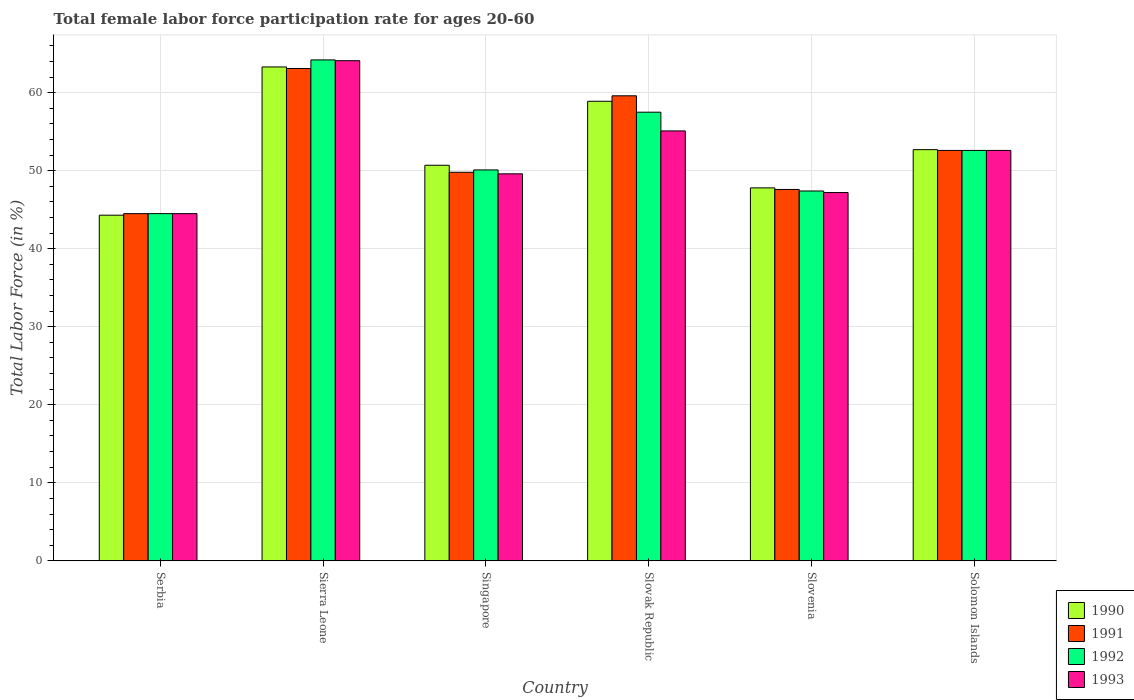How many groups of bars are there?
Provide a succinct answer. 6. Are the number of bars on each tick of the X-axis equal?
Provide a short and direct response. Yes. How many bars are there on the 1st tick from the left?
Provide a succinct answer. 4. How many bars are there on the 6th tick from the right?
Provide a succinct answer. 4. What is the label of the 1st group of bars from the left?
Offer a terse response. Serbia. In how many cases, is the number of bars for a given country not equal to the number of legend labels?
Give a very brief answer. 0. What is the female labor force participation rate in 1993 in Sierra Leone?
Make the answer very short. 64.1. Across all countries, what is the maximum female labor force participation rate in 1992?
Give a very brief answer. 64.2. Across all countries, what is the minimum female labor force participation rate in 1990?
Keep it short and to the point. 44.3. In which country was the female labor force participation rate in 1993 maximum?
Offer a terse response. Sierra Leone. In which country was the female labor force participation rate in 1993 minimum?
Your answer should be very brief. Serbia. What is the total female labor force participation rate in 1991 in the graph?
Your answer should be very brief. 317.2. What is the difference between the female labor force participation rate in 1993 in Slovak Republic and that in Slovenia?
Your answer should be compact. 7.9. What is the difference between the female labor force participation rate in 1991 in Slovenia and the female labor force participation rate in 1993 in Serbia?
Offer a terse response. 3.1. What is the average female labor force participation rate in 1991 per country?
Offer a terse response. 52.87. What is the difference between the female labor force participation rate of/in 1993 and female labor force participation rate of/in 1990 in Singapore?
Offer a terse response. -1.1. What is the ratio of the female labor force participation rate in 1990 in Sierra Leone to that in Slovenia?
Your answer should be compact. 1.32. Is the female labor force participation rate in 1991 in Sierra Leone less than that in Slovak Republic?
Your response must be concise. No. Is the difference between the female labor force participation rate in 1993 in Slovak Republic and Solomon Islands greater than the difference between the female labor force participation rate in 1990 in Slovak Republic and Solomon Islands?
Give a very brief answer. No. What is the difference between the highest and the second highest female labor force participation rate in 1992?
Your response must be concise. 6.7. What is the difference between the highest and the lowest female labor force participation rate in 1992?
Offer a very short reply. 19.7. Is it the case that in every country, the sum of the female labor force participation rate in 1992 and female labor force participation rate in 1993 is greater than the sum of female labor force participation rate in 1990 and female labor force participation rate in 1991?
Keep it short and to the point. No. What does the 3rd bar from the right in Solomon Islands represents?
Offer a very short reply. 1991. Is it the case that in every country, the sum of the female labor force participation rate in 1993 and female labor force participation rate in 1990 is greater than the female labor force participation rate in 1991?
Provide a short and direct response. Yes. How many bars are there?
Your answer should be compact. 24. Are all the bars in the graph horizontal?
Give a very brief answer. No. What is the difference between two consecutive major ticks on the Y-axis?
Your response must be concise. 10. Are the values on the major ticks of Y-axis written in scientific E-notation?
Give a very brief answer. No. Does the graph contain any zero values?
Offer a very short reply. No. Does the graph contain grids?
Keep it short and to the point. Yes. Where does the legend appear in the graph?
Give a very brief answer. Bottom right. What is the title of the graph?
Make the answer very short. Total female labor force participation rate for ages 20-60. What is the label or title of the Y-axis?
Ensure brevity in your answer.  Total Labor Force (in %). What is the Total Labor Force (in %) of 1990 in Serbia?
Offer a terse response. 44.3. What is the Total Labor Force (in %) of 1991 in Serbia?
Ensure brevity in your answer.  44.5. What is the Total Labor Force (in %) of 1992 in Serbia?
Make the answer very short. 44.5. What is the Total Labor Force (in %) in 1993 in Serbia?
Provide a succinct answer. 44.5. What is the Total Labor Force (in %) in 1990 in Sierra Leone?
Your answer should be very brief. 63.3. What is the Total Labor Force (in %) in 1991 in Sierra Leone?
Your response must be concise. 63.1. What is the Total Labor Force (in %) in 1992 in Sierra Leone?
Provide a short and direct response. 64.2. What is the Total Labor Force (in %) in 1993 in Sierra Leone?
Your answer should be very brief. 64.1. What is the Total Labor Force (in %) of 1990 in Singapore?
Your answer should be very brief. 50.7. What is the Total Labor Force (in %) in 1991 in Singapore?
Provide a succinct answer. 49.8. What is the Total Labor Force (in %) in 1992 in Singapore?
Your answer should be very brief. 50.1. What is the Total Labor Force (in %) of 1993 in Singapore?
Keep it short and to the point. 49.6. What is the Total Labor Force (in %) in 1990 in Slovak Republic?
Ensure brevity in your answer.  58.9. What is the Total Labor Force (in %) of 1991 in Slovak Republic?
Your answer should be compact. 59.6. What is the Total Labor Force (in %) of 1992 in Slovak Republic?
Your response must be concise. 57.5. What is the Total Labor Force (in %) in 1993 in Slovak Republic?
Ensure brevity in your answer.  55.1. What is the Total Labor Force (in %) of 1990 in Slovenia?
Offer a terse response. 47.8. What is the Total Labor Force (in %) in 1991 in Slovenia?
Provide a short and direct response. 47.6. What is the Total Labor Force (in %) in 1992 in Slovenia?
Ensure brevity in your answer.  47.4. What is the Total Labor Force (in %) in 1993 in Slovenia?
Your response must be concise. 47.2. What is the Total Labor Force (in %) in 1990 in Solomon Islands?
Ensure brevity in your answer.  52.7. What is the Total Labor Force (in %) of 1991 in Solomon Islands?
Your answer should be compact. 52.6. What is the Total Labor Force (in %) of 1992 in Solomon Islands?
Your answer should be very brief. 52.6. What is the Total Labor Force (in %) in 1993 in Solomon Islands?
Your answer should be very brief. 52.6. Across all countries, what is the maximum Total Labor Force (in %) in 1990?
Offer a very short reply. 63.3. Across all countries, what is the maximum Total Labor Force (in %) in 1991?
Provide a short and direct response. 63.1. Across all countries, what is the maximum Total Labor Force (in %) in 1992?
Your answer should be very brief. 64.2. Across all countries, what is the maximum Total Labor Force (in %) of 1993?
Your response must be concise. 64.1. Across all countries, what is the minimum Total Labor Force (in %) of 1990?
Your response must be concise. 44.3. Across all countries, what is the minimum Total Labor Force (in %) in 1991?
Make the answer very short. 44.5. Across all countries, what is the minimum Total Labor Force (in %) of 1992?
Provide a succinct answer. 44.5. Across all countries, what is the minimum Total Labor Force (in %) of 1993?
Offer a terse response. 44.5. What is the total Total Labor Force (in %) of 1990 in the graph?
Make the answer very short. 317.7. What is the total Total Labor Force (in %) in 1991 in the graph?
Ensure brevity in your answer.  317.2. What is the total Total Labor Force (in %) of 1992 in the graph?
Provide a succinct answer. 316.3. What is the total Total Labor Force (in %) in 1993 in the graph?
Keep it short and to the point. 313.1. What is the difference between the Total Labor Force (in %) of 1990 in Serbia and that in Sierra Leone?
Provide a short and direct response. -19. What is the difference between the Total Labor Force (in %) in 1991 in Serbia and that in Sierra Leone?
Keep it short and to the point. -18.6. What is the difference between the Total Labor Force (in %) of 1992 in Serbia and that in Sierra Leone?
Provide a short and direct response. -19.7. What is the difference between the Total Labor Force (in %) of 1993 in Serbia and that in Sierra Leone?
Offer a terse response. -19.6. What is the difference between the Total Labor Force (in %) of 1993 in Serbia and that in Singapore?
Provide a short and direct response. -5.1. What is the difference between the Total Labor Force (in %) in 1990 in Serbia and that in Slovak Republic?
Offer a very short reply. -14.6. What is the difference between the Total Labor Force (in %) in 1991 in Serbia and that in Slovak Republic?
Your answer should be compact. -15.1. What is the difference between the Total Labor Force (in %) in 1992 in Serbia and that in Slovak Republic?
Provide a short and direct response. -13. What is the difference between the Total Labor Force (in %) of 1993 in Serbia and that in Slovak Republic?
Your answer should be compact. -10.6. What is the difference between the Total Labor Force (in %) of 1990 in Serbia and that in Slovenia?
Keep it short and to the point. -3.5. What is the difference between the Total Labor Force (in %) in 1990 in Serbia and that in Solomon Islands?
Provide a short and direct response. -8.4. What is the difference between the Total Labor Force (in %) of 1991 in Serbia and that in Solomon Islands?
Keep it short and to the point. -8.1. What is the difference between the Total Labor Force (in %) in 1992 in Serbia and that in Solomon Islands?
Make the answer very short. -8.1. What is the difference between the Total Labor Force (in %) of 1993 in Serbia and that in Solomon Islands?
Your answer should be very brief. -8.1. What is the difference between the Total Labor Force (in %) in 1990 in Sierra Leone and that in Singapore?
Your response must be concise. 12.6. What is the difference between the Total Labor Force (in %) in 1991 in Sierra Leone and that in Singapore?
Ensure brevity in your answer.  13.3. What is the difference between the Total Labor Force (in %) of 1993 in Sierra Leone and that in Singapore?
Provide a succinct answer. 14.5. What is the difference between the Total Labor Force (in %) of 1990 in Sierra Leone and that in Slovak Republic?
Give a very brief answer. 4.4. What is the difference between the Total Labor Force (in %) in 1991 in Sierra Leone and that in Slovak Republic?
Offer a very short reply. 3.5. What is the difference between the Total Labor Force (in %) of 1993 in Sierra Leone and that in Slovak Republic?
Offer a terse response. 9. What is the difference between the Total Labor Force (in %) of 1990 in Sierra Leone and that in Slovenia?
Your answer should be compact. 15.5. What is the difference between the Total Labor Force (in %) in 1993 in Sierra Leone and that in Slovenia?
Keep it short and to the point. 16.9. What is the difference between the Total Labor Force (in %) in 1990 in Sierra Leone and that in Solomon Islands?
Make the answer very short. 10.6. What is the difference between the Total Labor Force (in %) of 1992 in Sierra Leone and that in Solomon Islands?
Ensure brevity in your answer.  11.6. What is the difference between the Total Labor Force (in %) in 1993 in Sierra Leone and that in Solomon Islands?
Provide a succinct answer. 11.5. What is the difference between the Total Labor Force (in %) in 1990 in Singapore and that in Slovak Republic?
Make the answer very short. -8.2. What is the difference between the Total Labor Force (in %) in 1991 in Singapore and that in Slovak Republic?
Offer a very short reply. -9.8. What is the difference between the Total Labor Force (in %) of 1992 in Singapore and that in Slovak Republic?
Your answer should be compact. -7.4. What is the difference between the Total Labor Force (in %) in 1990 in Singapore and that in Slovenia?
Your response must be concise. 2.9. What is the difference between the Total Labor Force (in %) in 1991 in Singapore and that in Slovenia?
Provide a succinct answer. 2.2. What is the difference between the Total Labor Force (in %) of 1992 in Singapore and that in Slovenia?
Your answer should be compact. 2.7. What is the difference between the Total Labor Force (in %) of 1993 in Singapore and that in Solomon Islands?
Your response must be concise. -3. What is the difference between the Total Labor Force (in %) of 1991 in Slovak Republic and that in Slovenia?
Provide a succinct answer. 12. What is the difference between the Total Labor Force (in %) of 1991 in Slovak Republic and that in Solomon Islands?
Offer a very short reply. 7. What is the difference between the Total Labor Force (in %) in 1992 in Slovak Republic and that in Solomon Islands?
Your response must be concise. 4.9. What is the difference between the Total Labor Force (in %) of 1993 in Slovak Republic and that in Solomon Islands?
Ensure brevity in your answer.  2.5. What is the difference between the Total Labor Force (in %) of 1992 in Slovenia and that in Solomon Islands?
Offer a terse response. -5.2. What is the difference between the Total Labor Force (in %) of 1993 in Slovenia and that in Solomon Islands?
Provide a short and direct response. -5.4. What is the difference between the Total Labor Force (in %) of 1990 in Serbia and the Total Labor Force (in %) of 1991 in Sierra Leone?
Offer a terse response. -18.8. What is the difference between the Total Labor Force (in %) in 1990 in Serbia and the Total Labor Force (in %) in 1992 in Sierra Leone?
Offer a very short reply. -19.9. What is the difference between the Total Labor Force (in %) in 1990 in Serbia and the Total Labor Force (in %) in 1993 in Sierra Leone?
Your answer should be compact. -19.8. What is the difference between the Total Labor Force (in %) of 1991 in Serbia and the Total Labor Force (in %) of 1992 in Sierra Leone?
Provide a succinct answer. -19.7. What is the difference between the Total Labor Force (in %) of 1991 in Serbia and the Total Labor Force (in %) of 1993 in Sierra Leone?
Your answer should be compact. -19.6. What is the difference between the Total Labor Force (in %) in 1992 in Serbia and the Total Labor Force (in %) in 1993 in Sierra Leone?
Ensure brevity in your answer.  -19.6. What is the difference between the Total Labor Force (in %) in 1990 in Serbia and the Total Labor Force (in %) in 1991 in Singapore?
Make the answer very short. -5.5. What is the difference between the Total Labor Force (in %) of 1990 in Serbia and the Total Labor Force (in %) of 1993 in Singapore?
Make the answer very short. -5.3. What is the difference between the Total Labor Force (in %) in 1990 in Serbia and the Total Labor Force (in %) in 1991 in Slovak Republic?
Give a very brief answer. -15.3. What is the difference between the Total Labor Force (in %) in 1990 in Serbia and the Total Labor Force (in %) in 1992 in Slovak Republic?
Keep it short and to the point. -13.2. What is the difference between the Total Labor Force (in %) of 1990 in Serbia and the Total Labor Force (in %) of 1993 in Slovak Republic?
Provide a short and direct response. -10.8. What is the difference between the Total Labor Force (in %) in 1991 in Serbia and the Total Labor Force (in %) in 1992 in Slovak Republic?
Offer a very short reply. -13. What is the difference between the Total Labor Force (in %) in 1991 in Serbia and the Total Labor Force (in %) in 1993 in Slovak Republic?
Your answer should be compact. -10.6. What is the difference between the Total Labor Force (in %) of 1992 in Serbia and the Total Labor Force (in %) of 1993 in Slovak Republic?
Your response must be concise. -10.6. What is the difference between the Total Labor Force (in %) of 1990 in Serbia and the Total Labor Force (in %) of 1991 in Slovenia?
Offer a terse response. -3.3. What is the difference between the Total Labor Force (in %) in 1991 in Serbia and the Total Labor Force (in %) in 1992 in Slovenia?
Provide a short and direct response. -2.9. What is the difference between the Total Labor Force (in %) of 1992 in Serbia and the Total Labor Force (in %) of 1993 in Slovenia?
Offer a very short reply. -2.7. What is the difference between the Total Labor Force (in %) in 1990 in Serbia and the Total Labor Force (in %) in 1992 in Solomon Islands?
Make the answer very short. -8.3. What is the difference between the Total Labor Force (in %) in 1990 in Serbia and the Total Labor Force (in %) in 1993 in Solomon Islands?
Your answer should be very brief. -8.3. What is the difference between the Total Labor Force (in %) in 1991 in Serbia and the Total Labor Force (in %) in 1993 in Solomon Islands?
Provide a short and direct response. -8.1. What is the difference between the Total Labor Force (in %) of 1992 in Serbia and the Total Labor Force (in %) of 1993 in Solomon Islands?
Offer a very short reply. -8.1. What is the difference between the Total Labor Force (in %) of 1990 in Sierra Leone and the Total Labor Force (in %) of 1991 in Singapore?
Your answer should be very brief. 13.5. What is the difference between the Total Labor Force (in %) in 1990 in Sierra Leone and the Total Labor Force (in %) in 1993 in Singapore?
Give a very brief answer. 13.7. What is the difference between the Total Labor Force (in %) in 1990 in Sierra Leone and the Total Labor Force (in %) in 1992 in Slovak Republic?
Provide a succinct answer. 5.8. What is the difference between the Total Labor Force (in %) in 1990 in Sierra Leone and the Total Labor Force (in %) in 1993 in Slovak Republic?
Your answer should be very brief. 8.2. What is the difference between the Total Labor Force (in %) of 1991 in Sierra Leone and the Total Labor Force (in %) of 1993 in Slovak Republic?
Offer a terse response. 8. What is the difference between the Total Labor Force (in %) of 1992 in Sierra Leone and the Total Labor Force (in %) of 1993 in Slovak Republic?
Offer a terse response. 9.1. What is the difference between the Total Labor Force (in %) of 1990 in Sierra Leone and the Total Labor Force (in %) of 1993 in Slovenia?
Provide a short and direct response. 16.1. What is the difference between the Total Labor Force (in %) in 1992 in Sierra Leone and the Total Labor Force (in %) in 1993 in Slovenia?
Offer a terse response. 17. What is the difference between the Total Labor Force (in %) of 1990 in Sierra Leone and the Total Labor Force (in %) of 1992 in Solomon Islands?
Provide a short and direct response. 10.7. What is the difference between the Total Labor Force (in %) of 1990 in Sierra Leone and the Total Labor Force (in %) of 1993 in Solomon Islands?
Provide a succinct answer. 10.7. What is the difference between the Total Labor Force (in %) in 1991 in Sierra Leone and the Total Labor Force (in %) in 1993 in Solomon Islands?
Your answer should be compact. 10.5. What is the difference between the Total Labor Force (in %) of 1990 in Singapore and the Total Labor Force (in %) of 1991 in Slovak Republic?
Your response must be concise. -8.9. What is the difference between the Total Labor Force (in %) of 1990 in Singapore and the Total Labor Force (in %) of 1992 in Slovak Republic?
Your answer should be very brief. -6.8. What is the difference between the Total Labor Force (in %) in 1991 in Singapore and the Total Labor Force (in %) in 1992 in Slovak Republic?
Provide a succinct answer. -7.7. What is the difference between the Total Labor Force (in %) in 1990 in Singapore and the Total Labor Force (in %) in 1991 in Slovenia?
Make the answer very short. 3.1. What is the difference between the Total Labor Force (in %) of 1990 in Singapore and the Total Labor Force (in %) of 1992 in Slovenia?
Offer a terse response. 3.3. What is the difference between the Total Labor Force (in %) in 1990 in Singapore and the Total Labor Force (in %) in 1993 in Slovenia?
Offer a terse response. 3.5. What is the difference between the Total Labor Force (in %) of 1991 in Singapore and the Total Labor Force (in %) of 1992 in Slovenia?
Keep it short and to the point. 2.4. What is the difference between the Total Labor Force (in %) of 1992 in Singapore and the Total Labor Force (in %) of 1993 in Slovenia?
Provide a short and direct response. 2.9. What is the difference between the Total Labor Force (in %) in 1990 in Singapore and the Total Labor Force (in %) in 1991 in Solomon Islands?
Keep it short and to the point. -1.9. What is the difference between the Total Labor Force (in %) in 1990 in Singapore and the Total Labor Force (in %) in 1993 in Solomon Islands?
Your response must be concise. -1.9. What is the difference between the Total Labor Force (in %) of 1992 in Singapore and the Total Labor Force (in %) of 1993 in Solomon Islands?
Ensure brevity in your answer.  -2.5. What is the difference between the Total Labor Force (in %) of 1990 in Slovak Republic and the Total Labor Force (in %) of 1991 in Slovenia?
Your answer should be very brief. 11.3. What is the difference between the Total Labor Force (in %) of 1990 in Slovak Republic and the Total Labor Force (in %) of 1992 in Slovenia?
Keep it short and to the point. 11.5. What is the difference between the Total Labor Force (in %) in 1991 in Slovak Republic and the Total Labor Force (in %) in 1992 in Slovenia?
Provide a succinct answer. 12.2. What is the difference between the Total Labor Force (in %) of 1991 in Slovak Republic and the Total Labor Force (in %) of 1993 in Slovenia?
Provide a succinct answer. 12.4. What is the difference between the Total Labor Force (in %) of 1990 in Slovak Republic and the Total Labor Force (in %) of 1991 in Solomon Islands?
Keep it short and to the point. 6.3. What is the difference between the Total Labor Force (in %) of 1990 in Slovak Republic and the Total Labor Force (in %) of 1993 in Solomon Islands?
Your answer should be very brief. 6.3. What is the difference between the Total Labor Force (in %) of 1991 in Slovak Republic and the Total Labor Force (in %) of 1992 in Solomon Islands?
Make the answer very short. 7. What is the difference between the Total Labor Force (in %) in 1990 in Slovenia and the Total Labor Force (in %) in 1991 in Solomon Islands?
Provide a succinct answer. -4.8. What is the difference between the Total Labor Force (in %) of 1990 in Slovenia and the Total Labor Force (in %) of 1992 in Solomon Islands?
Offer a terse response. -4.8. What is the difference between the Total Labor Force (in %) in 1991 in Slovenia and the Total Labor Force (in %) in 1992 in Solomon Islands?
Offer a very short reply. -5. What is the difference between the Total Labor Force (in %) in 1991 in Slovenia and the Total Labor Force (in %) in 1993 in Solomon Islands?
Provide a short and direct response. -5. What is the average Total Labor Force (in %) of 1990 per country?
Your answer should be very brief. 52.95. What is the average Total Labor Force (in %) of 1991 per country?
Provide a short and direct response. 52.87. What is the average Total Labor Force (in %) of 1992 per country?
Your response must be concise. 52.72. What is the average Total Labor Force (in %) of 1993 per country?
Keep it short and to the point. 52.18. What is the difference between the Total Labor Force (in %) of 1990 and Total Labor Force (in %) of 1992 in Serbia?
Keep it short and to the point. -0.2. What is the difference between the Total Labor Force (in %) in 1990 and Total Labor Force (in %) in 1993 in Serbia?
Give a very brief answer. -0.2. What is the difference between the Total Labor Force (in %) of 1991 and Total Labor Force (in %) of 1992 in Serbia?
Your answer should be very brief. 0. What is the difference between the Total Labor Force (in %) of 1992 and Total Labor Force (in %) of 1993 in Serbia?
Your answer should be compact. 0. What is the difference between the Total Labor Force (in %) of 1990 and Total Labor Force (in %) of 1991 in Sierra Leone?
Offer a terse response. 0.2. What is the difference between the Total Labor Force (in %) in 1990 and Total Labor Force (in %) in 1992 in Sierra Leone?
Give a very brief answer. -0.9. What is the difference between the Total Labor Force (in %) in 1990 and Total Labor Force (in %) in 1993 in Sierra Leone?
Offer a terse response. -0.8. What is the difference between the Total Labor Force (in %) in 1991 and Total Labor Force (in %) in 1992 in Sierra Leone?
Your answer should be compact. -1.1. What is the difference between the Total Labor Force (in %) in 1992 and Total Labor Force (in %) in 1993 in Sierra Leone?
Offer a terse response. 0.1. What is the difference between the Total Labor Force (in %) of 1990 and Total Labor Force (in %) of 1991 in Singapore?
Your answer should be very brief. 0.9. What is the difference between the Total Labor Force (in %) of 1990 and Total Labor Force (in %) of 1992 in Singapore?
Your answer should be compact. 0.6. What is the difference between the Total Labor Force (in %) of 1991 and Total Labor Force (in %) of 1993 in Singapore?
Ensure brevity in your answer.  0.2. What is the difference between the Total Labor Force (in %) of 1992 and Total Labor Force (in %) of 1993 in Slovak Republic?
Keep it short and to the point. 2.4. What is the difference between the Total Labor Force (in %) of 1990 and Total Labor Force (in %) of 1992 in Slovenia?
Your response must be concise. 0.4. What is the difference between the Total Labor Force (in %) in 1991 and Total Labor Force (in %) in 1993 in Slovenia?
Offer a very short reply. 0.4. What is the difference between the Total Labor Force (in %) of 1992 and Total Labor Force (in %) of 1993 in Slovenia?
Your response must be concise. 0.2. What is the difference between the Total Labor Force (in %) in 1990 and Total Labor Force (in %) in 1991 in Solomon Islands?
Your response must be concise. 0.1. What is the difference between the Total Labor Force (in %) in 1990 and Total Labor Force (in %) in 1992 in Solomon Islands?
Offer a very short reply. 0.1. What is the difference between the Total Labor Force (in %) in 1990 and Total Labor Force (in %) in 1993 in Solomon Islands?
Make the answer very short. 0.1. What is the difference between the Total Labor Force (in %) in 1991 and Total Labor Force (in %) in 1993 in Solomon Islands?
Give a very brief answer. 0. What is the ratio of the Total Labor Force (in %) in 1990 in Serbia to that in Sierra Leone?
Offer a very short reply. 0.7. What is the ratio of the Total Labor Force (in %) of 1991 in Serbia to that in Sierra Leone?
Give a very brief answer. 0.71. What is the ratio of the Total Labor Force (in %) of 1992 in Serbia to that in Sierra Leone?
Keep it short and to the point. 0.69. What is the ratio of the Total Labor Force (in %) in 1993 in Serbia to that in Sierra Leone?
Ensure brevity in your answer.  0.69. What is the ratio of the Total Labor Force (in %) in 1990 in Serbia to that in Singapore?
Your response must be concise. 0.87. What is the ratio of the Total Labor Force (in %) in 1991 in Serbia to that in Singapore?
Keep it short and to the point. 0.89. What is the ratio of the Total Labor Force (in %) in 1992 in Serbia to that in Singapore?
Offer a very short reply. 0.89. What is the ratio of the Total Labor Force (in %) of 1993 in Serbia to that in Singapore?
Keep it short and to the point. 0.9. What is the ratio of the Total Labor Force (in %) in 1990 in Serbia to that in Slovak Republic?
Ensure brevity in your answer.  0.75. What is the ratio of the Total Labor Force (in %) in 1991 in Serbia to that in Slovak Republic?
Provide a succinct answer. 0.75. What is the ratio of the Total Labor Force (in %) of 1992 in Serbia to that in Slovak Republic?
Ensure brevity in your answer.  0.77. What is the ratio of the Total Labor Force (in %) of 1993 in Serbia to that in Slovak Republic?
Keep it short and to the point. 0.81. What is the ratio of the Total Labor Force (in %) in 1990 in Serbia to that in Slovenia?
Make the answer very short. 0.93. What is the ratio of the Total Labor Force (in %) of 1991 in Serbia to that in Slovenia?
Ensure brevity in your answer.  0.93. What is the ratio of the Total Labor Force (in %) in 1992 in Serbia to that in Slovenia?
Keep it short and to the point. 0.94. What is the ratio of the Total Labor Force (in %) of 1993 in Serbia to that in Slovenia?
Your answer should be very brief. 0.94. What is the ratio of the Total Labor Force (in %) of 1990 in Serbia to that in Solomon Islands?
Ensure brevity in your answer.  0.84. What is the ratio of the Total Labor Force (in %) in 1991 in Serbia to that in Solomon Islands?
Make the answer very short. 0.85. What is the ratio of the Total Labor Force (in %) of 1992 in Serbia to that in Solomon Islands?
Your response must be concise. 0.85. What is the ratio of the Total Labor Force (in %) in 1993 in Serbia to that in Solomon Islands?
Your answer should be compact. 0.85. What is the ratio of the Total Labor Force (in %) of 1990 in Sierra Leone to that in Singapore?
Your answer should be very brief. 1.25. What is the ratio of the Total Labor Force (in %) in 1991 in Sierra Leone to that in Singapore?
Ensure brevity in your answer.  1.27. What is the ratio of the Total Labor Force (in %) of 1992 in Sierra Leone to that in Singapore?
Keep it short and to the point. 1.28. What is the ratio of the Total Labor Force (in %) in 1993 in Sierra Leone to that in Singapore?
Give a very brief answer. 1.29. What is the ratio of the Total Labor Force (in %) of 1990 in Sierra Leone to that in Slovak Republic?
Ensure brevity in your answer.  1.07. What is the ratio of the Total Labor Force (in %) of 1991 in Sierra Leone to that in Slovak Republic?
Give a very brief answer. 1.06. What is the ratio of the Total Labor Force (in %) of 1992 in Sierra Leone to that in Slovak Republic?
Make the answer very short. 1.12. What is the ratio of the Total Labor Force (in %) of 1993 in Sierra Leone to that in Slovak Republic?
Provide a succinct answer. 1.16. What is the ratio of the Total Labor Force (in %) in 1990 in Sierra Leone to that in Slovenia?
Provide a short and direct response. 1.32. What is the ratio of the Total Labor Force (in %) of 1991 in Sierra Leone to that in Slovenia?
Keep it short and to the point. 1.33. What is the ratio of the Total Labor Force (in %) of 1992 in Sierra Leone to that in Slovenia?
Give a very brief answer. 1.35. What is the ratio of the Total Labor Force (in %) in 1993 in Sierra Leone to that in Slovenia?
Your answer should be very brief. 1.36. What is the ratio of the Total Labor Force (in %) in 1990 in Sierra Leone to that in Solomon Islands?
Your response must be concise. 1.2. What is the ratio of the Total Labor Force (in %) of 1991 in Sierra Leone to that in Solomon Islands?
Give a very brief answer. 1.2. What is the ratio of the Total Labor Force (in %) of 1992 in Sierra Leone to that in Solomon Islands?
Your answer should be compact. 1.22. What is the ratio of the Total Labor Force (in %) in 1993 in Sierra Leone to that in Solomon Islands?
Your response must be concise. 1.22. What is the ratio of the Total Labor Force (in %) of 1990 in Singapore to that in Slovak Republic?
Make the answer very short. 0.86. What is the ratio of the Total Labor Force (in %) of 1991 in Singapore to that in Slovak Republic?
Give a very brief answer. 0.84. What is the ratio of the Total Labor Force (in %) of 1992 in Singapore to that in Slovak Republic?
Ensure brevity in your answer.  0.87. What is the ratio of the Total Labor Force (in %) of 1993 in Singapore to that in Slovak Republic?
Ensure brevity in your answer.  0.9. What is the ratio of the Total Labor Force (in %) of 1990 in Singapore to that in Slovenia?
Your answer should be very brief. 1.06. What is the ratio of the Total Labor Force (in %) in 1991 in Singapore to that in Slovenia?
Provide a short and direct response. 1.05. What is the ratio of the Total Labor Force (in %) in 1992 in Singapore to that in Slovenia?
Your answer should be compact. 1.06. What is the ratio of the Total Labor Force (in %) of 1993 in Singapore to that in Slovenia?
Provide a short and direct response. 1.05. What is the ratio of the Total Labor Force (in %) in 1990 in Singapore to that in Solomon Islands?
Ensure brevity in your answer.  0.96. What is the ratio of the Total Labor Force (in %) in 1991 in Singapore to that in Solomon Islands?
Offer a terse response. 0.95. What is the ratio of the Total Labor Force (in %) in 1992 in Singapore to that in Solomon Islands?
Your response must be concise. 0.95. What is the ratio of the Total Labor Force (in %) in 1993 in Singapore to that in Solomon Islands?
Provide a succinct answer. 0.94. What is the ratio of the Total Labor Force (in %) in 1990 in Slovak Republic to that in Slovenia?
Provide a short and direct response. 1.23. What is the ratio of the Total Labor Force (in %) of 1991 in Slovak Republic to that in Slovenia?
Your response must be concise. 1.25. What is the ratio of the Total Labor Force (in %) of 1992 in Slovak Republic to that in Slovenia?
Give a very brief answer. 1.21. What is the ratio of the Total Labor Force (in %) in 1993 in Slovak Republic to that in Slovenia?
Offer a very short reply. 1.17. What is the ratio of the Total Labor Force (in %) of 1990 in Slovak Republic to that in Solomon Islands?
Give a very brief answer. 1.12. What is the ratio of the Total Labor Force (in %) of 1991 in Slovak Republic to that in Solomon Islands?
Keep it short and to the point. 1.13. What is the ratio of the Total Labor Force (in %) of 1992 in Slovak Republic to that in Solomon Islands?
Offer a very short reply. 1.09. What is the ratio of the Total Labor Force (in %) in 1993 in Slovak Republic to that in Solomon Islands?
Your answer should be very brief. 1.05. What is the ratio of the Total Labor Force (in %) in 1990 in Slovenia to that in Solomon Islands?
Provide a succinct answer. 0.91. What is the ratio of the Total Labor Force (in %) in 1991 in Slovenia to that in Solomon Islands?
Offer a very short reply. 0.9. What is the ratio of the Total Labor Force (in %) of 1992 in Slovenia to that in Solomon Islands?
Offer a very short reply. 0.9. What is the ratio of the Total Labor Force (in %) of 1993 in Slovenia to that in Solomon Islands?
Offer a very short reply. 0.9. What is the difference between the highest and the second highest Total Labor Force (in %) in 1990?
Your response must be concise. 4.4. What is the difference between the highest and the second highest Total Labor Force (in %) in 1992?
Offer a terse response. 6.7. What is the difference between the highest and the lowest Total Labor Force (in %) of 1990?
Your answer should be very brief. 19. What is the difference between the highest and the lowest Total Labor Force (in %) of 1992?
Provide a short and direct response. 19.7. What is the difference between the highest and the lowest Total Labor Force (in %) in 1993?
Offer a terse response. 19.6. 